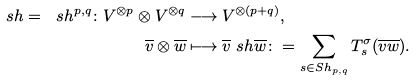Convert formula to latex. <formula><loc_0><loc_0><loc_500><loc_500>\ s h = \ s h ^ { p , q } \colon V ^ { \otimes p } \otimes V ^ { \otimes q } & \longrightarrow V ^ { \otimes ( p + q ) } , \\ \overline { v } \otimes \overline { w } & \longmapsto \overline { v } \ s h \overline { w } \colon = \sum _ { s \in S h _ { p , q } } T _ { s } ^ { \sigma } ( \overline { v } \overline { w } ) .</formula> 